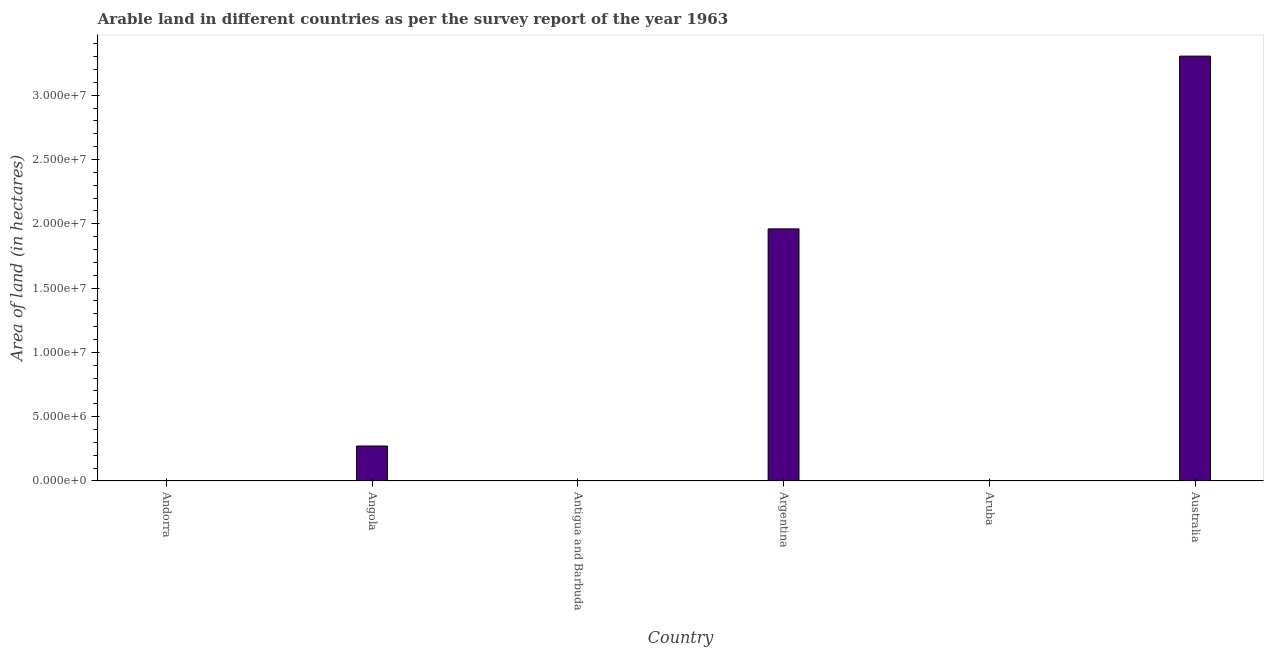Does the graph contain grids?
Your answer should be very brief. No. What is the title of the graph?
Offer a very short reply. Arable land in different countries as per the survey report of the year 1963. What is the label or title of the Y-axis?
Your answer should be very brief. Area of land (in hectares). What is the area of land in Antigua and Barbuda?
Give a very brief answer. 8000. Across all countries, what is the maximum area of land?
Provide a short and direct response. 3.30e+07. In which country was the area of land maximum?
Your response must be concise. Australia. In which country was the area of land minimum?
Make the answer very short. Andorra. What is the sum of the area of land?
Make the answer very short. 5.54e+07. What is the difference between the area of land in Andorra and Angola?
Your answer should be very brief. -2.72e+06. What is the average area of land per country?
Offer a terse response. 9.23e+06. What is the median area of land?
Give a very brief answer. 1.36e+06. Is the difference between the area of land in Angola and Australia greater than the difference between any two countries?
Provide a succinct answer. No. What is the difference between the highest and the second highest area of land?
Your answer should be compact. 1.34e+07. What is the difference between the highest and the lowest area of land?
Make the answer very short. 3.30e+07. In how many countries, is the area of land greater than the average area of land taken over all countries?
Your answer should be very brief. 2. Are all the bars in the graph horizontal?
Provide a succinct answer. No. How many countries are there in the graph?
Offer a very short reply. 6. What is the difference between two consecutive major ticks on the Y-axis?
Your response must be concise. 5.00e+06. What is the Area of land (in hectares) in Angola?
Your answer should be very brief. 2.72e+06. What is the Area of land (in hectares) of Antigua and Barbuda?
Provide a short and direct response. 8000. What is the Area of land (in hectares) in Argentina?
Give a very brief answer. 1.96e+07. What is the Area of land (in hectares) in Australia?
Ensure brevity in your answer.  3.30e+07. What is the difference between the Area of land (in hectares) in Andorra and Angola?
Offer a terse response. -2.72e+06. What is the difference between the Area of land (in hectares) in Andorra and Antigua and Barbuda?
Offer a terse response. -7000. What is the difference between the Area of land (in hectares) in Andorra and Argentina?
Ensure brevity in your answer.  -1.96e+07. What is the difference between the Area of land (in hectares) in Andorra and Aruba?
Your response must be concise. -1000. What is the difference between the Area of land (in hectares) in Andorra and Australia?
Keep it short and to the point. -3.30e+07. What is the difference between the Area of land (in hectares) in Angola and Antigua and Barbuda?
Your response must be concise. 2.71e+06. What is the difference between the Area of land (in hectares) in Angola and Argentina?
Provide a succinct answer. -1.69e+07. What is the difference between the Area of land (in hectares) in Angola and Aruba?
Give a very brief answer. 2.72e+06. What is the difference between the Area of land (in hectares) in Angola and Australia?
Make the answer very short. -3.03e+07. What is the difference between the Area of land (in hectares) in Antigua and Barbuda and Argentina?
Offer a terse response. -1.96e+07. What is the difference between the Area of land (in hectares) in Antigua and Barbuda and Aruba?
Make the answer very short. 6000. What is the difference between the Area of land (in hectares) in Antigua and Barbuda and Australia?
Your answer should be very brief. -3.30e+07. What is the difference between the Area of land (in hectares) in Argentina and Aruba?
Offer a terse response. 1.96e+07. What is the difference between the Area of land (in hectares) in Argentina and Australia?
Provide a succinct answer. -1.34e+07. What is the difference between the Area of land (in hectares) in Aruba and Australia?
Your response must be concise. -3.30e+07. What is the ratio of the Area of land (in hectares) in Andorra to that in Angola?
Provide a short and direct response. 0. What is the ratio of the Area of land (in hectares) in Andorra to that in Antigua and Barbuda?
Provide a succinct answer. 0.12. What is the ratio of the Area of land (in hectares) in Andorra to that in Aruba?
Keep it short and to the point. 0.5. What is the ratio of the Area of land (in hectares) in Angola to that in Antigua and Barbuda?
Provide a succinct answer. 340. What is the ratio of the Area of land (in hectares) in Angola to that in Argentina?
Provide a succinct answer. 0.14. What is the ratio of the Area of land (in hectares) in Angola to that in Aruba?
Provide a short and direct response. 1360. What is the ratio of the Area of land (in hectares) in Angola to that in Australia?
Offer a very short reply. 0.08. What is the ratio of the Area of land (in hectares) in Antigua and Barbuda to that in Australia?
Ensure brevity in your answer.  0. What is the ratio of the Area of land (in hectares) in Argentina to that in Aruba?
Ensure brevity in your answer.  9800. What is the ratio of the Area of land (in hectares) in Argentina to that in Australia?
Provide a short and direct response. 0.59. 